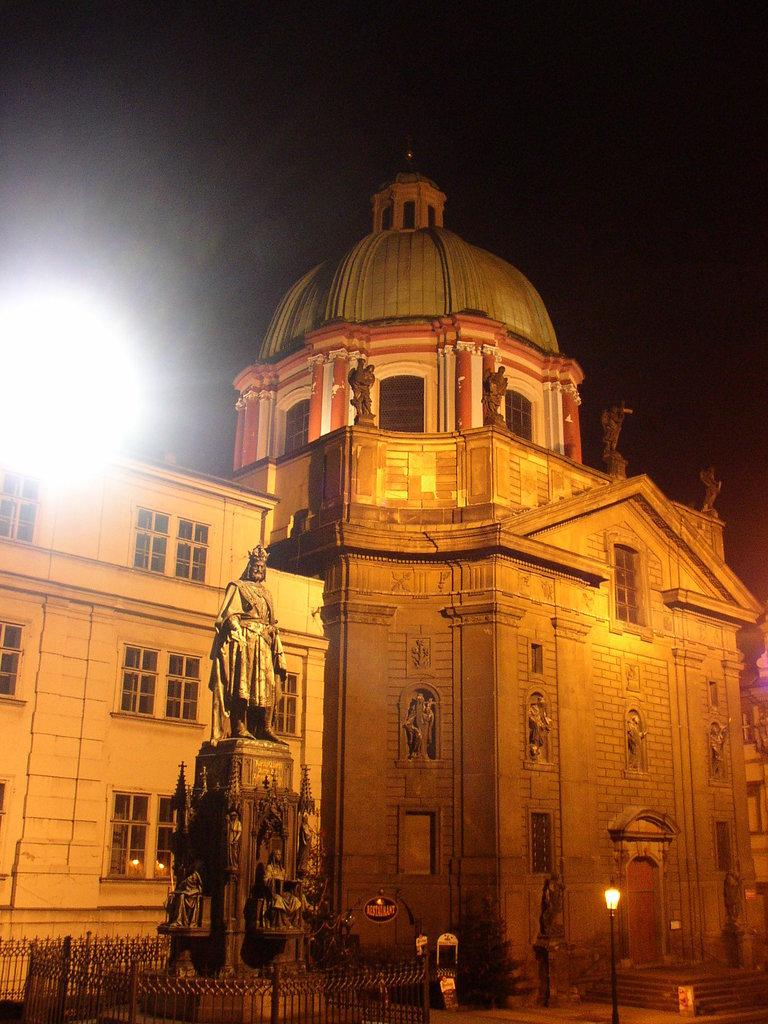What is the main subject in the image? There is a statue in the image. What is surrounding the statue? The statue has a fence around it. What can be seen behind the statue? There is a building behind the statue. Where is the light located in the image? There is a light in the left corner of the image. What type of juice is being served at the event in the image? There is no event or juice present in the image; it features a statue with a fence around it, a building in the background, and a light in the left corner. 